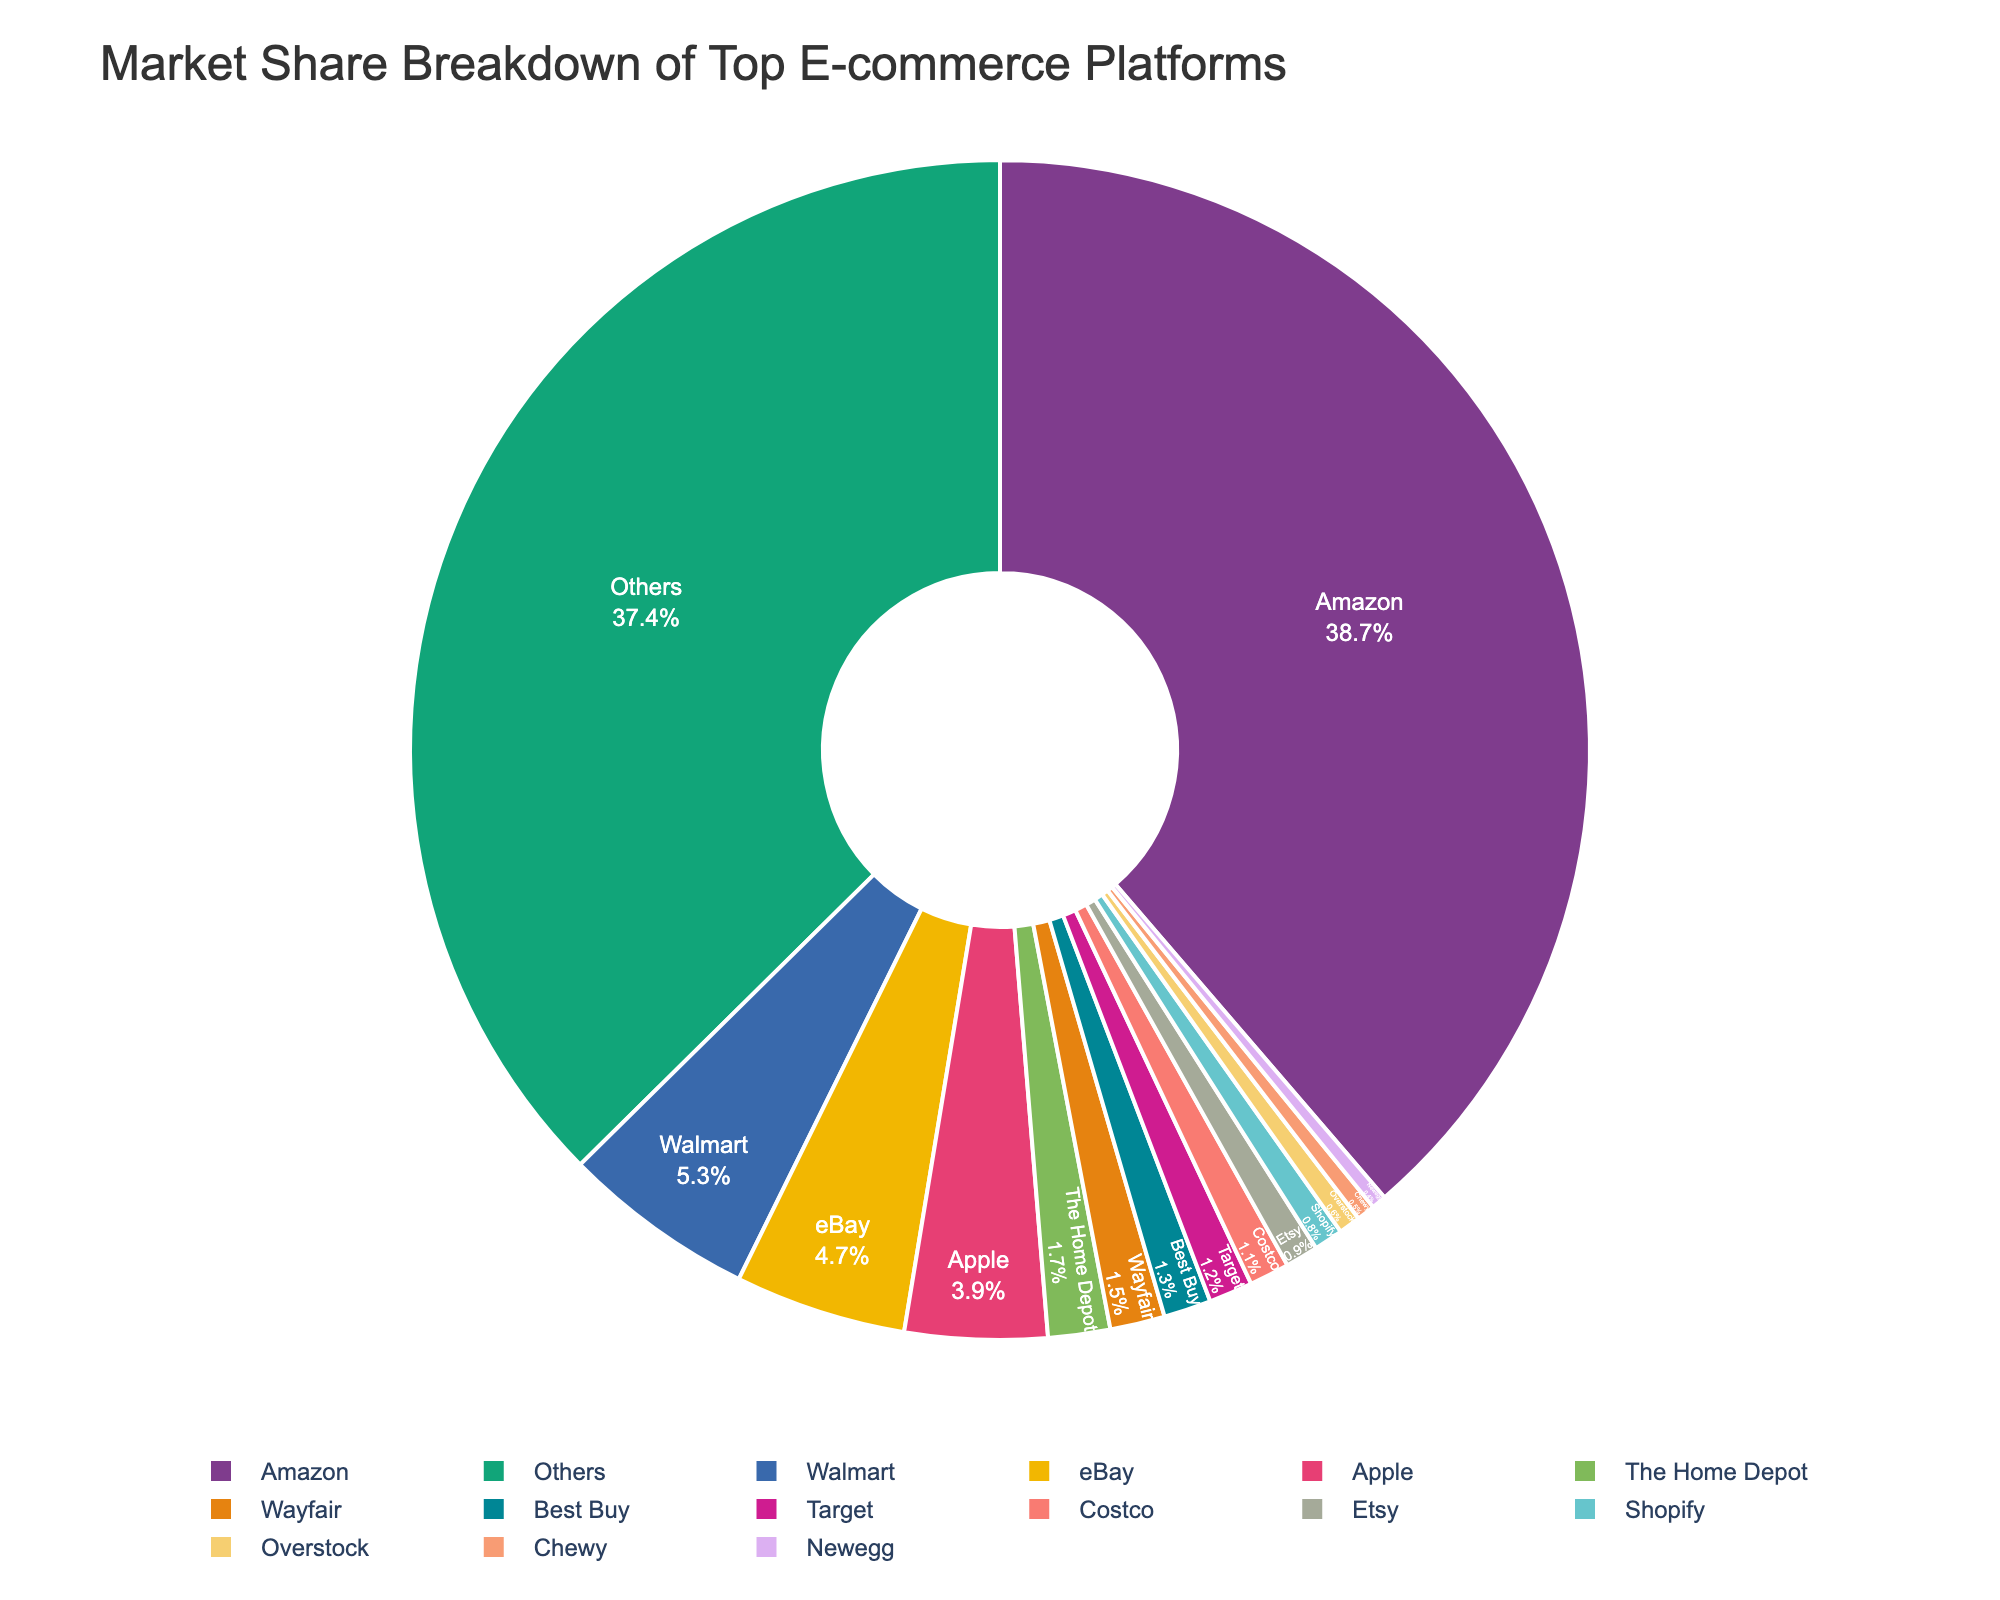What is the market share of Amazon? Identifying Amazon's share in the chart, it is labeled as 38.7%. Therefore, Amazon's market share is 38.7%.
Answer: 38.7% Which company has the second highest market share? By observing the pie chart, Walmart holds the second largest segment with a market share of 5.3%.
Answer: Walmart What is the combined market share of Apple and The Home Depot? Looking at the chart, Apple has a 3.9% share and The Home Depot has a 1.7% share. Adding these together gives 3.9% + 1.7% = 5.6%.
Answer: 5.6% How does Wayfair's market share compare to Best Buy's? From the pie chart, Wayfair has a market share of 1.5%, while Best Buy has 1.3%. Comparing these, Wayfair has a slightly higher market share than Best Buy.
Answer: Wayfair has a higher share than Best Buy What is the combined market share of the companies (not including 'Others') with less than 2% each? The companies with less than 2% market share each are Wayfair (1.5%), Best Buy (1.3%), Target (1.2%), Costco (1.1%), Etsy (0.9%), Shopify (0.8%), Overstock (0.6%), Chewy (0.5%), and Newegg (0.4%). Adding these together: 1.5% + 1.3% + 1.2% + 1.1% + 0.9% + 0.8% + 0.6% + 0.5% + 0.4% = 8.3%.
Answer: 8.3% If the top three companies combine their market shares, what percentage do they hold together? The top three companies are Amazon (38.7%), Walmart (5.3%), and eBay (4.7%). Adding their market shares together: 38.7% + 5.3% + 4.7% = 48.7%.
Answer: 48.7% What is the difference in market share between the company with the largest share and the company with the smallest share (excluding 'Others')? Excluding 'Others', Amazon has the largest market share at 38.7%. Newegg has the smallest market share at 0.4%. The difference is 38.7% - 0.4% = 38.3%.
Answer: 38.3% Which company has a green-colored segment? Examining the pie chart's colors, Apple's segment is represented in green.
Answer: Apple What percentage of the market share do companies other than the "Others" category hold collectively? The pie chart shows the "Others" category holding 37.4%. Therefore, the remaining market share is 100% - 37.4% = 62.6%, which is held by the named companies.
Answer: 62.6% 